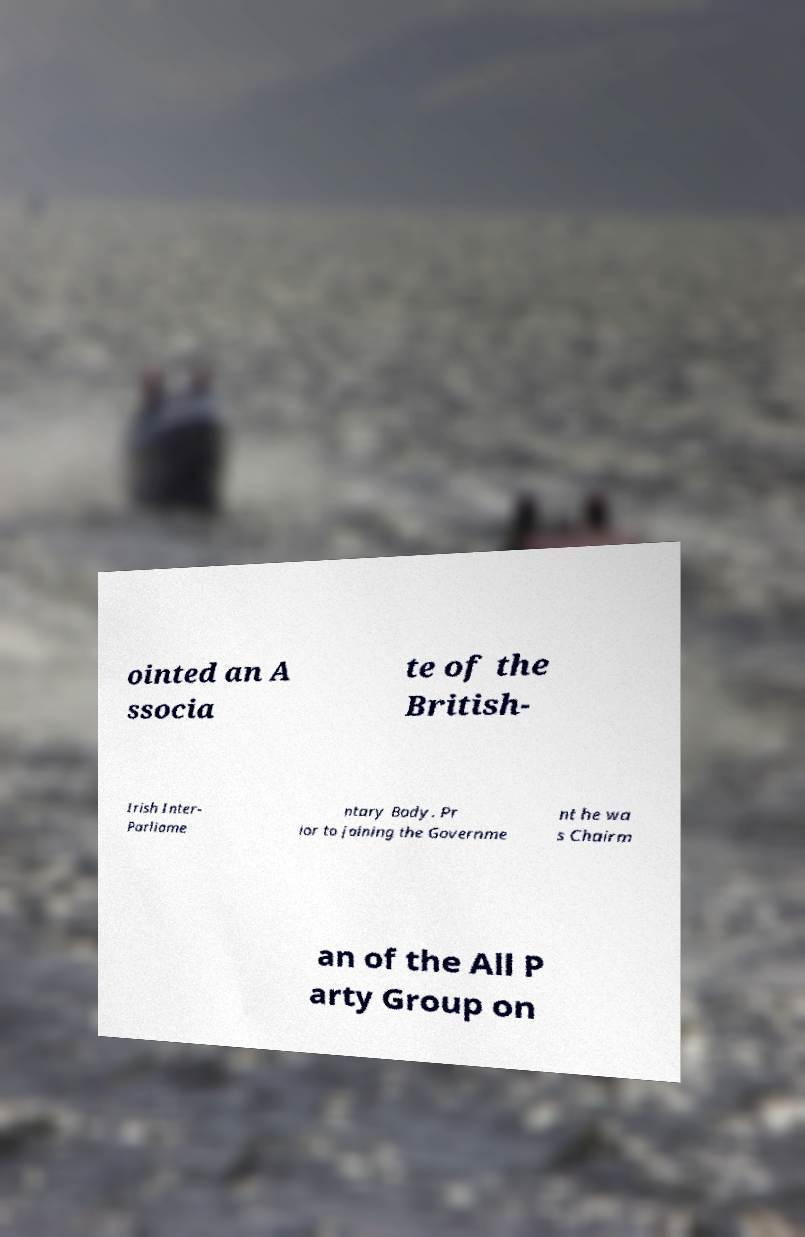Can you read and provide the text displayed in the image?This photo seems to have some interesting text. Can you extract and type it out for me? ointed an A ssocia te of the British- Irish Inter- Parliame ntary Body. Pr ior to joining the Governme nt he wa s Chairm an of the All P arty Group on 